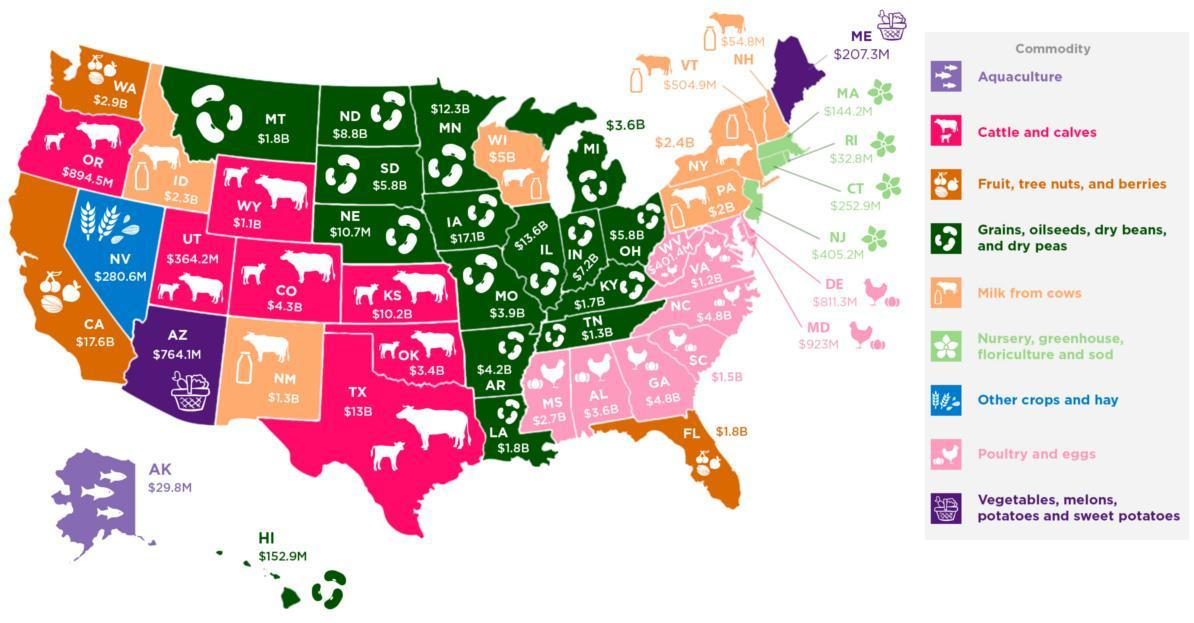In which state Other crops and hay is present?
Answer the question with a short phrase. NV What is the rate of commodity Aquaculture in the state AK? $29.8M Which commodity is found in the state HI? Grains, oilseeds, dry beans and dry peas What is the rate of the commodity Milk in the state NM? $1.3B In which state of the United states, Aqua culture is present? AK What is the rate of commodity Fruit, tree nuts and berries in the state CA? $17.6B In how many states trees nuts, fruits and berries are located? 3 In how many states of United states Nursery, Green House, floriculture, sod are found? 4 Which commodity is found in the state NV? Other crops and hay In how many states of United States Cattle and Calves are present? 7 